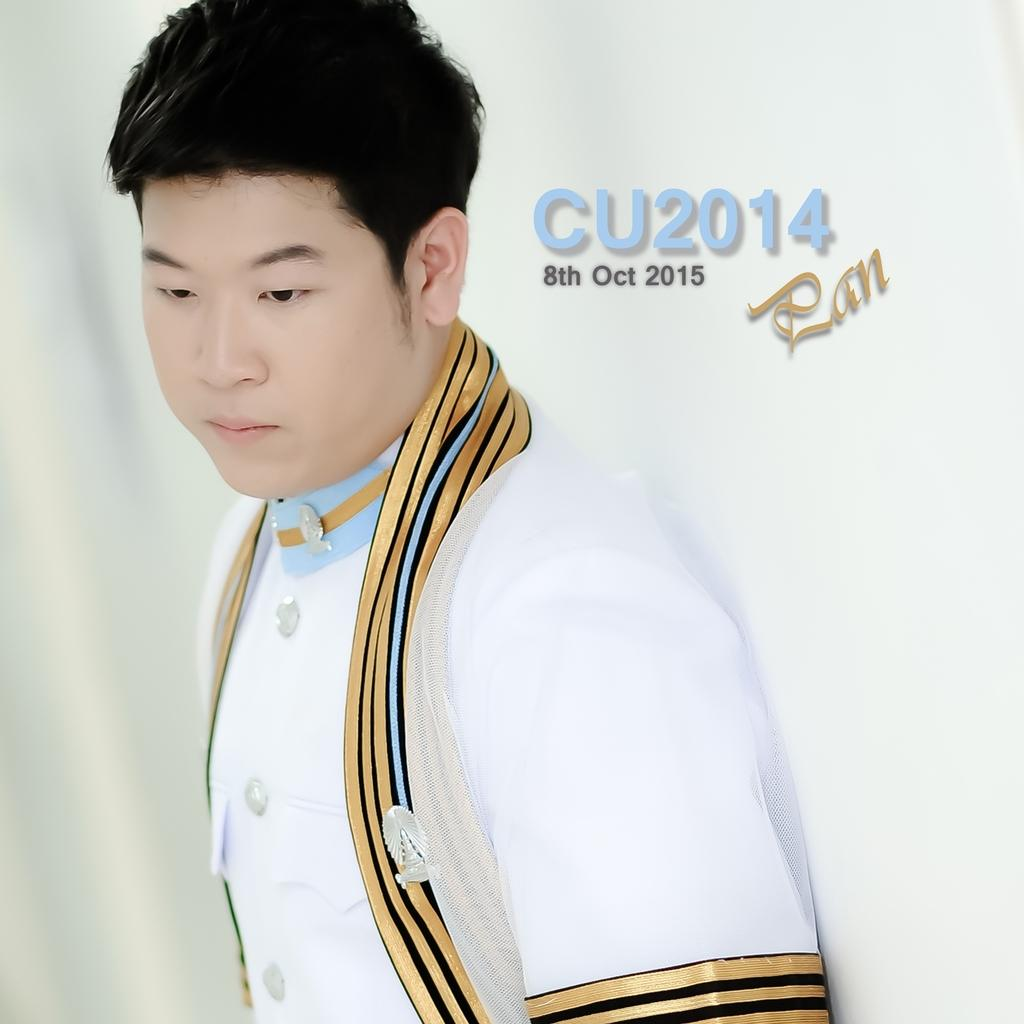Who is present in the image? There is a man in the image. What is the man wearing? The man is wearing a white and gold color dress. What is the background of the image? There is a white color cloth behind the man. Are there any words visible on the image? Yes, there are black color words on the image. What type of shade does the farmer use to protect the popcorn in the image? There is no farmer, popcorn, or shade present in the image. 